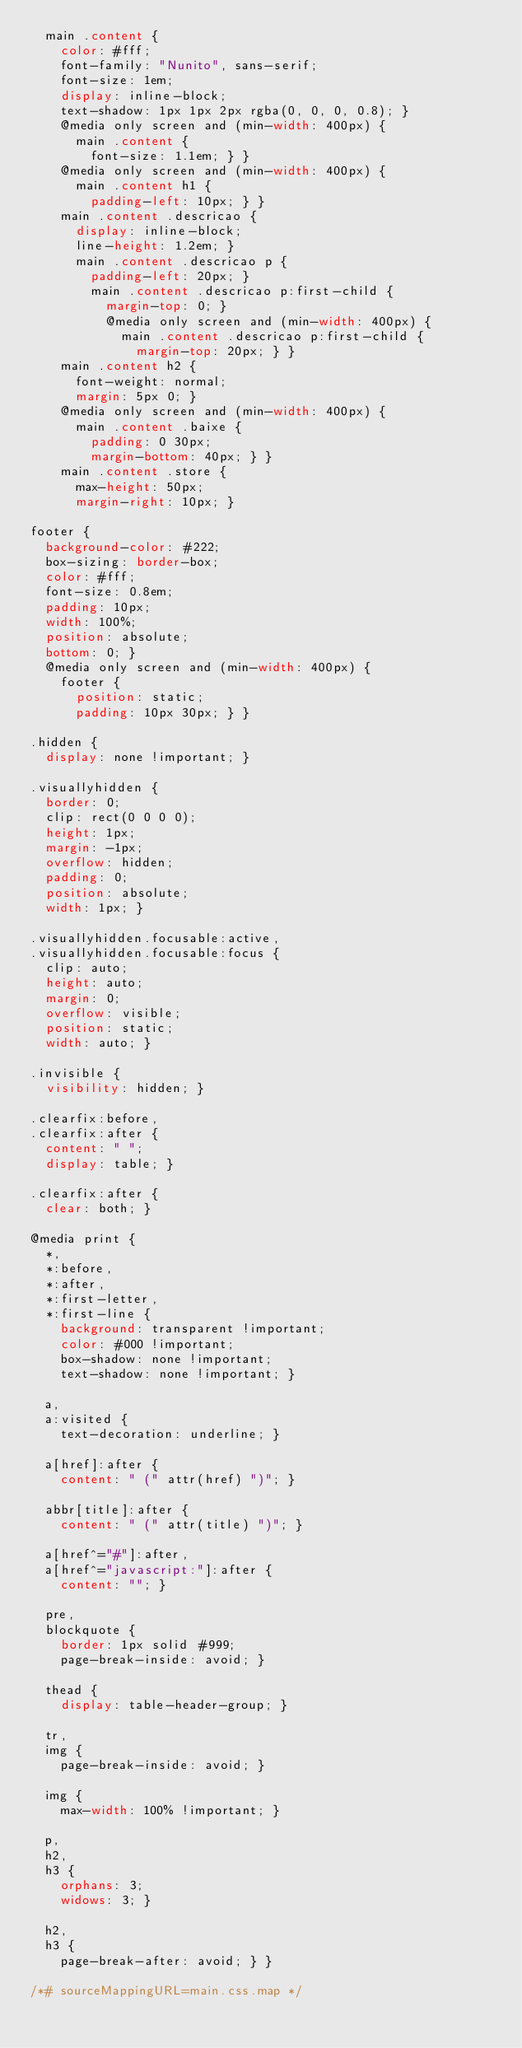Convert code to text. <code><loc_0><loc_0><loc_500><loc_500><_CSS_>  main .content {
    color: #fff;
    font-family: "Nunito", sans-serif;
    font-size: 1em;
    display: inline-block;
    text-shadow: 1px 1px 2px rgba(0, 0, 0, 0.8); }
    @media only screen and (min-width: 400px) {
      main .content {
        font-size: 1.1em; } }
    @media only screen and (min-width: 400px) {
      main .content h1 {
        padding-left: 10px; } }
    main .content .descricao {
      display: inline-block;
      line-height: 1.2em; }
      main .content .descricao p {
        padding-left: 20px; }
        main .content .descricao p:first-child {
          margin-top: 0; }
          @media only screen and (min-width: 400px) {
            main .content .descricao p:first-child {
              margin-top: 20px; } }
    main .content h2 {
      font-weight: normal;
      margin: 5px 0; }
    @media only screen and (min-width: 400px) {
      main .content .baixe {
        padding: 0 30px;
        margin-bottom: 40px; } }
    main .content .store {
      max-height: 50px;
      margin-right: 10px; }

footer {
  background-color: #222;
  box-sizing: border-box;
  color: #fff;
  font-size: 0.8em;
  padding: 10px;
  width: 100%;
  position: absolute;
  bottom: 0; }
  @media only screen and (min-width: 400px) {
    footer {
      position: static;
      padding: 10px 30px; } }

.hidden {
  display: none !important; }

.visuallyhidden {
  border: 0;
  clip: rect(0 0 0 0);
  height: 1px;
  margin: -1px;
  overflow: hidden;
  padding: 0;
  position: absolute;
  width: 1px; }

.visuallyhidden.focusable:active,
.visuallyhidden.focusable:focus {
  clip: auto;
  height: auto;
  margin: 0;
  overflow: visible;
  position: static;
  width: auto; }

.invisible {
  visibility: hidden; }

.clearfix:before,
.clearfix:after {
  content: " ";
  display: table; }

.clearfix:after {
  clear: both; }

@media print {
  *,
  *:before,
  *:after,
  *:first-letter,
  *:first-line {
    background: transparent !important;
    color: #000 !important;
    box-shadow: none !important;
    text-shadow: none !important; }

  a,
  a:visited {
    text-decoration: underline; }

  a[href]:after {
    content: " (" attr(href) ")"; }

  abbr[title]:after {
    content: " (" attr(title) ")"; }

  a[href^="#"]:after,
  a[href^="javascript:"]:after {
    content: ""; }

  pre,
  blockquote {
    border: 1px solid #999;
    page-break-inside: avoid; }

  thead {
    display: table-header-group; }

  tr,
  img {
    page-break-inside: avoid; }

  img {
    max-width: 100% !important; }

  p,
  h2,
  h3 {
    orphans: 3;
    widows: 3; }

  h2,
  h3 {
    page-break-after: avoid; } }

/*# sourceMappingURL=main.css.map */
</code> 